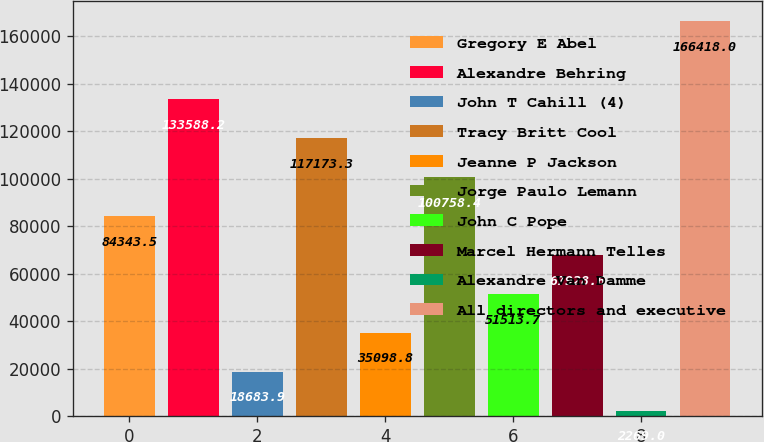Convert chart to OTSL. <chart><loc_0><loc_0><loc_500><loc_500><bar_chart><fcel>Gregory E Abel<fcel>Alexandre Behring<fcel>John T Cahill (4)<fcel>Tracy Britt Cool<fcel>Jeanne P Jackson<fcel>Jorge Paulo Lemann<fcel>John C Pope<fcel>Marcel Hermann Telles<fcel>Alexandre Van Damme<fcel>All directors and executive<nl><fcel>84343.5<fcel>133588<fcel>18683.9<fcel>117173<fcel>35098.8<fcel>100758<fcel>51513.7<fcel>67928.6<fcel>2269<fcel>166418<nl></chart> 